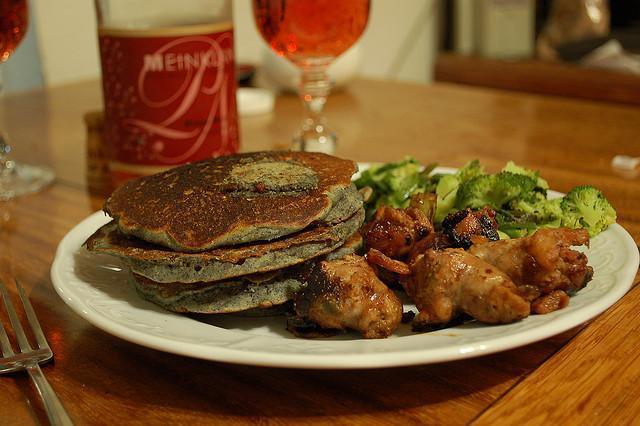How many tines does the fork have?
Give a very brief answer. 3. How many pancakes are there?
Give a very brief answer. 3. How many forks are there?
Give a very brief answer. 1. How many forks are in the photo?
Give a very brief answer. 1. How many plates are there?
Give a very brief answer. 1. How many dining tables are there?
Give a very brief answer. 2. How many wine glasses are there?
Give a very brief answer. 2. 